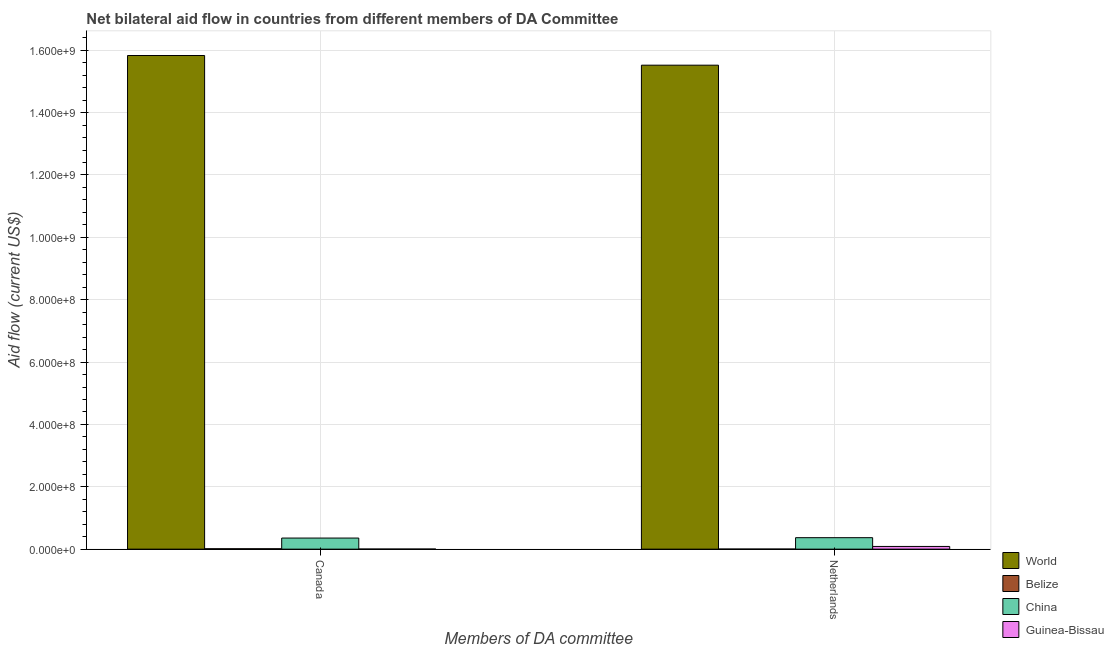How many different coloured bars are there?
Offer a terse response. 4. How many bars are there on the 2nd tick from the right?
Keep it short and to the point. 4. What is the amount of aid given by netherlands in China?
Make the answer very short. 3.68e+07. Across all countries, what is the maximum amount of aid given by netherlands?
Give a very brief answer. 1.55e+09. Across all countries, what is the minimum amount of aid given by netherlands?
Ensure brevity in your answer.  2.50e+05. In which country was the amount of aid given by canada minimum?
Make the answer very short. Guinea-Bissau. What is the total amount of aid given by canada in the graph?
Offer a terse response. 1.62e+09. What is the difference between the amount of aid given by netherlands in World and that in Belize?
Offer a terse response. 1.55e+09. What is the difference between the amount of aid given by canada in World and the amount of aid given by netherlands in Guinea-Bissau?
Offer a terse response. 1.57e+09. What is the average amount of aid given by canada per country?
Your answer should be compact. 4.05e+08. What is the difference between the amount of aid given by netherlands and amount of aid given by canada in Belize?
Give a very brief answer. -1.05e+06. What is the ratio of the amount of aid given by canada in Guinea-Bissau to that in Belize?
Offer a terse response. 0.23. Is the amount of aid given by netherlands in China less than that in Guinea-Bissau?
Offer a very short reply. No. In how many countries, is the amount of aid given by netherlands greater than the average amount of aid given by netherlands taken over all countries?
Your response must be concise. 1. What does the 4th bar from the left in Netherlands represents?
Give a very brief answer. Guinea-Bissau. What does the 2nd bar from the right in Canada represents?
Keep it short and to the point. China. How many bars are there?
Ensure brevity in your answer.  8. Are all the bars in the graph horizontal?
Give a very brief answer. No. What is the difference between two consecutive major ticks on the Y-axis?
Make the answer very short. 2.00e+08. Does the graph contain any zero values?
Ensure brevity in your answer.  No. Does the graph contain grids?
Provide a succinct answer. Yes. How are the legend labels stacked?
Provide a short and direct response. Vertical. What is the title of the graph?
Ensure brevity in your answer.  Net bilateral aid flow in countries from different members of DA Committee. Does "Sao Tome and Principe" appear as one of the legend labels in the graph?
Your answer should be compact. No. What is the label or title of the X-axis?
Make the answer very short. Members of DA committee. What is the label or title of the Y-axis?
Provide a succinct answer. Aid flow (current US$). What is the Aid flow (current US$) of World in Canada?
Make the answer very short. 1.58e+09. What is the Aid flow (current US$) of Belize in Canada?
Your answer should be compact. 1.30e+06. What is the Aid flow (current US$) of China in Canada?
Offer a very short reply. 3.56e+07. What is the Aid flow (current US$) in Guinea-Bissau in Canada?
Keep it short and to the point. 3.00e+05. What is the Aid flow (current US$) of World in Netherlands?
Your answer should be compact. 1.55e+09. What is the Aid flow (current US$) of Belize in Netherlands?
Your answer should be compact. 2.50e+05. What is the Aid flow (current US$) in China in Netherlands?
Your response must be concise. 3.68e+07. What is the Aid flow (current US$) of Guinea-Bissau in Netherlands?
Make the answer very short. 8.67e+06. Across all Members of DA committee, what is the maximum Aid flow (current US$) in World?
Give a very brief answer. 1.58e+09. Across all Members of DA committee, what is the maximum Aid flow (current US$) of Belize?
Your response must be concise. 1.30e+06. Across all Members of DA committee, what is the maximum Aid flow (current US$) of China?
Offer a terse response. 3.68e+07. Across all Members of DA committee, what is the maximum Aid flow (current US$) in Guinea-Bissau?
Provide a short and direct response. 8.67e+06. Across all Members of DA committee, what is the minimum Aid flow (current US$) in World?
Provide a succinct answer. 1.55e+09. Across all Members of DA committee, what is the minimum Aid flow (current US$) of Belize?
Provide a succinct answer. 2.50e+05. Across all Members of DA committee, what is the minimum Aid flow (current US$) in China?
Give a very brief answer. 3.56e+07. Across all Members of DA committee, what is the minimum Aid flow (current US$) in Guinea-Bissau?
Offer a terse response. 3.00e+05. What is the total Aid flow (current US$) in World in the graph?
Offer a terse response. 3.14e+09. What is the total Aid flow (current US$) in Belize in the graph?
Offer a terse response. 1.55e+06. What is the total Aid flow (current US$) in China in the graph?
Provide a succinct answer. 7.24e+07. What is the total Aid flow (current US$) of Guinea-Bissau in the graph?
Your response must be concise. 8.97e+06. What is the difference between the Aid flow (current US$) in World in Canada and that in Netherlands?
Provide a succinct answer. 3.10e+07. What is the difference between the Aid flow (current US$) in Belize in Canada and that in Netherlands?
Keep it short and to the point. 1.05e+06. What is the difference between the Aid flow (current US$) of China in Canada and that in Netherlands?
Provide a succinct answer. -1.20e+06. What is the difference between the Aid flow (current US$) of Guinea-Bissau in Canada and that in Netherlands?
Your answer should be compact. -8.37e+06. What is the difference between the Aid flow (current US$) of World in Canada and the Aid flow (current US$) of Belize in Netherlands?
Keep it short and to the point. 1.58e+09. What is the difference between the Aid flow (current US$) in World in Canada and the Aid flow (current US$) in China in Netherlands?
Your response must be concise. 1.55e+09. What is the difference between the Aid flow (current US$) of World in Canada and the Aid flow (current US$) of Guinea-Bissau in Netherlands?
Ensure brevity in your answer.  1.57e+09. What is the difference between the Aid flow (current US$) of Belize in Canada and the Aid flow (current US$) of China in Netherlands?
Your answer should be very brief. -3.55e+07. What is the difference between the Aid flow (current US$) of Belize in Canada and the Aid flow (current US$) of Guinea-Bissau in Netherlands?
Your response must be concise. -7.37e+06. What is the difference between the Aid flow (current US$) in China in Canada and the Aid flow (current US$) in Guinea-Bissau in Netherlands?
Your answer should be compact. 2.69e+07. What is the average Aid flow (current US$) in World per Members of DA committee?
Provide a succinct answer. 1.57e+09. What is the average Aid flow (current US$) in Belize per Members of DA committee?
Your answer should be very brief. 7.75e+05. What is the average Aid flow (current US$) of China per Members of DA committee?
Ensure brevity in your answer.  3.62e+07. What is the average Aid flow (current US$) in Guinea-Bissau per Members of DA committee?
Ensure brevity in your answer.  4.48e+06. What is the difference between the Aid flow (current US$) in World and Aid flow (current US$) in Belize in Canada?
Give a very brief answer. 1.58e+09. What is the difference between the Aid flow (current US$) of World and Aid flow (current US$) of China in Canada?
Offer a terse response. 1.55e+09. What is the difference between the Aid flow (current US$) of World and Aid flow (current US$) of Guinea-Bissau in Canada?
Ensure brevity in your answer.  1.58e+09. What is the difference between the Aid flow (current US$) of Belize and Aid flow (current US$) of China in Canada?
Ensure brevity in your answer.  -3.43e+07. What is the difference between the Aid flow (current US$) of Belize and Aid flow (current US$) of Guinea-Bissau in Canada?
Your answer should be very brief. 1.00e+06. What is the difference between the Aid flow (current US$) of China and Aid flow (current US$) of Guinea-Bissau in Canada?
Keep it short and to the point. 3.53e+07. What is the difference between the Aid flow (current US$) of World and Aid flow (current US$) of Belize in Netherlands?
Keep it short and to the point. 1.55e+09. What is the difference between the Aid flow (current US$) in World and Aid flow (current US$) in China in Netherlands?
Offer a very short reply. 1.52e+09. What is the difference between the Aid flow (current US$) in World and Aid flow (current US$) in Guinea-Bissau in Netherlands?
Your answer should be very brief. 1.54e+09. What is the difference between the Aid flow (current US$) in Belize and Aid flow (current US$) in China in Netherlands?
Provide a succinct answer. -3.66e+07. What is the difference between the Aid flow (current US$) of Belize and Aid flow (current US$) of Guinea-Bissau in Netherlands?
Give a very brief answer. -8.42e+06. What is the difference between the Aid flow (current US$) of China and Aid flow (current US$) of Guinea-Bissau in Netherlands?
Your response must be concise. 2.81e+07. What is the ratio of the Aid flow (current US$) of Belize in Canada to that in Netherlands?
Provide a succinct answer. 5.2. What is the ratio of the Aid flow (current US$) in China in Canada to that in Netherlands?
Give a very brief answer. 0.97. What is the ratio of the Aid flow (current US$) in Guinea-Bissau in Canada to that in Netherlands?
Give a very brief answer. 0.03. What is the difference between the highest and the second highest Aid flow (current US$) of World?
Provide a succinct answer. 3.10e+07. What is the difference between the highest and the second highest Aid flow (current US$) in Belize?
Provide a short and direct response. 1.05e+06. What is the difference between the highest and the second highest Aid flow (current US$) of China?
Your answer should be very brief. 1.20e+06. What is the difference between the highest and the second highest Aid flow (current US$) in Guinea-Bissau?
Make the answer very short. 8.37e+06. What is the difference between the highest and the lowest Aid flow (current US$) of World?
Provide a short and direct response. 3.10e+07. What is the difference between the highest and the lowest Aid flow (current US$) of Belize?
Provide a short and direct response. 1.05e+06. What is the difference between the highest and the lowest Aid flow (current US$) of China?
Offer a terse response. 1.20e+06. What is the difference between the highest and the lowest Aid flow (current US$) of Guinea-Bissau?
Provide a short and direct response. 8.37e+06. 